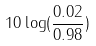<formula> <loc_0><loc_0><loc_500><loc_500>1 0 \log ( \frac { 0 . 0 2 } { 0 . 9 8 } )</formula> 